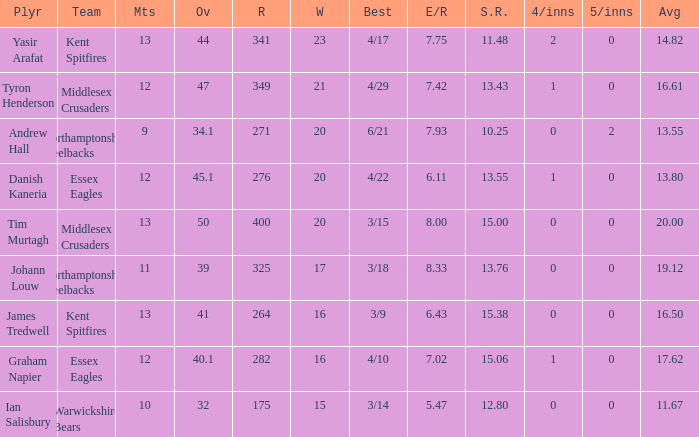Name the most 4/inns 2.0. 